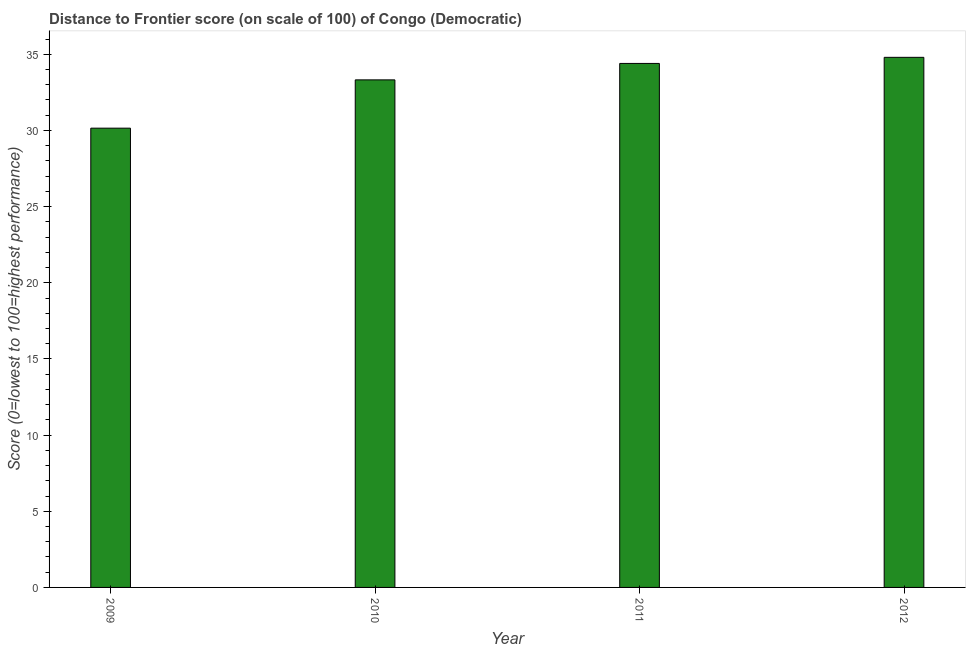Does the graph contain any zero values?
Offer a terse response. No. Does the graph contain grids?
Give a very brief answer. No. What is the title of the graph?
Make the answer very short. Distance to Frontier score (on scale of 100) of Congo (Democratic). What is the label or title of the X-axis?
Your response must be concise. Year. What is the label or title of the Y-axis?
Keep it short and to the point. Score (0=lowest to 100=highest performance). What is the distance to frontier score in 2009?
Provide a short and direct response. 30.15. Across all years, what is the maximum distance to frontier score?
Offer a very short reply. 34.8. Across all years, what is the minimum distance to frontier score?
Your response must be concise. 30.15. In which year was the distance to frontier score maximum?
Make the answer very short. 2012. What is the sum of the distance to frontier score?
Keep it short and to the point. 132.67. What is the difference between the distance to frontier score in 2009 and 2011?
Keep it short and to the point. -4.25. What is the average distance to frontier score per year?
Your answer should be very brief. 33.17. What is the median distance to frontier score?
Your answer should be very brief. 33.86. Do a majority of the years between 2010 and 2012 (inclusive) have distance to frontier score greater than 27 ?
Provide a succinct answer. Yes. What is the ratio of the distance to frontier score in 2010 to that in 2011?
Your response must be concise. 0.97. Is the sum of the distance to frontier score in 2010 and 2011 greater than the maximum distance to frontier score across all years?
Keep it short and to the point. Yes. What is the difference between the highest and the lowest distance to frontier score?
Provide a succinct answer. 4.65. In how many years, is the distance to frontier score greater than the average distance to frontier score taken over all years?
Give a very brief answer. 3. How many bars are there?
Offer a very short reply. 4. Are all the bars in the graph horizontal?
Offer a terse response. No. How many years are there in the graph?
Offer a very short reply. 4. What is the difference between two consecutive major ticks on the Y-axis?
Your response must be concise. 5. Are the values on the major ticks of Y-axis written in scientific E-notation?
Keep it short and to the point. No. What is the Score (0=lowest to 100=highest performance) in 2009?
Your response must be concise. 30.15. What is the Score (0=lowest to 100=highest performance) of 2010?
Your answer should be compact. 33.32. What is the Score (0=lowest to 100=highest performance) in 2011?
Ensure brevity in your answer.  34.4. What is the Score (0=lowest to 100=highest performance) of 2012?
Your answer should be compact. 34.8. What is the difference between the Score (0=lowest to 100=highest performance) in 2009 and 2010?
Offer a terse response. -3.17. What is the difference between the Score (0=lowest to 100=highest performance) in 2009 and 2011?
Your answer should be very brief. -4.25. What is the difference between the Score (0=lowest to 100=highest performance) in 2009 and 2012?
Offer a terse response. -4.65. What is the difference between the Score (0=lowest to 100=highest performance) in 2010 and 2011?
Give a very brief answer. -1.08. What is the difference between the Score (0=lowest to 100=highest performance) in 2010 and 2012?
Ensure brevity in your answer.  -1.48. What is the difference between the Score (0=lowest to 100=highest performance) in 2011 and 2012?
Ensure brevity in your answer.  -0.4. What is the ratio of the Score (0=lowest to 100=highest performance) in 2009 to that in 2010?
Ensure brevity in your answer.  0.91. What is the ratio of the Score (0=lowest to 100=highest performance) in 2009 to that in 2011?
Make the answer very short. 0.88. What is the ratio of the Score (0=lowest to 100=highest performance) in 2009 to that in 2012?
Your answer should be compact. 0.87. What is the ratio of the Score (0=lowest to 100=highest performance) in 2011 to that in 2012?
Your answer should be very brief. 0.99. 